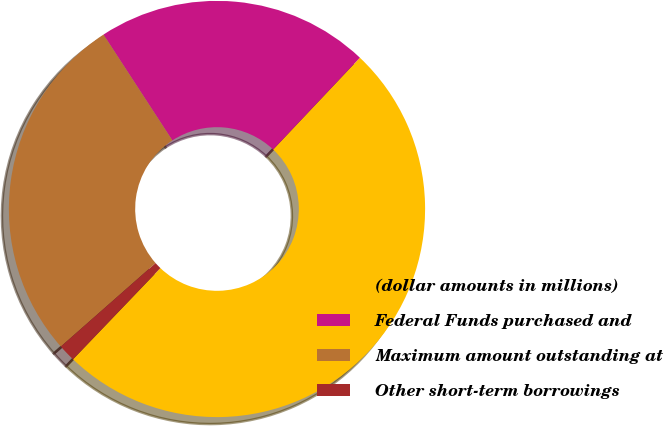<chart> <loc_0><loc_0><loc_500><loc_500><pie_chart><fcel>(dollar amounts in millions)<fcel>Federal Funds purchased and<fcel>Maximum amount outstanding at<fcel>Other short-term borrowings<nl><fcel>50.11%<fcel>21.23%<fcel>27.31%<fcel>1.35%<nl></chart> 